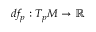Convert formula to latex. <formula><loc_0><loc_0><loc_500><loc_500>d f _ { p } \colon T _ { p } M \to \mathbb { R }</formula> 